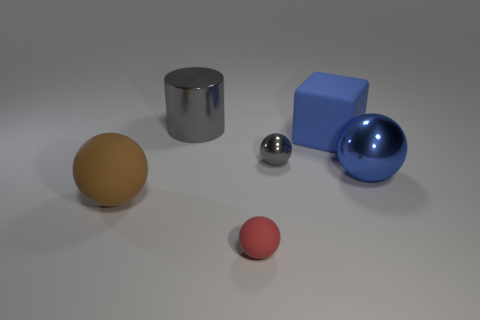What is the color of the shiny ball that is right of the blue object that is left of the large blue ball?
Keep it short and to the point. Blue. Is there a small block of the same color as the tiny matte sphere?
Provide a succinct answer. No. What number of rubber objects are gray cylinders or tiny yellow cylinders?
Ensure brevity in your answer.  0. Are there any red blocks made of the same material as the gray ball?
Give a very brief answer. No. What number of things are both on the left side of the big blue metallic thing and in front of the large blue block?
Make the answer very short. 3. Are there fewer big blue objects that are behind the blue ball than gray things in front of the large rubber sphere?
Your response must be concise. No. Is the shape of the big blue shiny object the same as the tiny gray metal thing?
Provide a succinct answer. Yes. How many other things are there of the same size as the blue metallic sphere?
Give a very brief answer. 3. What number of objects are small balls behind the blue ball or things that are right of the red thing?
Provide a short and direct response. 3. How many big purple things are the same shape as the big blue metallic object?
Your response must be concise. 0. 